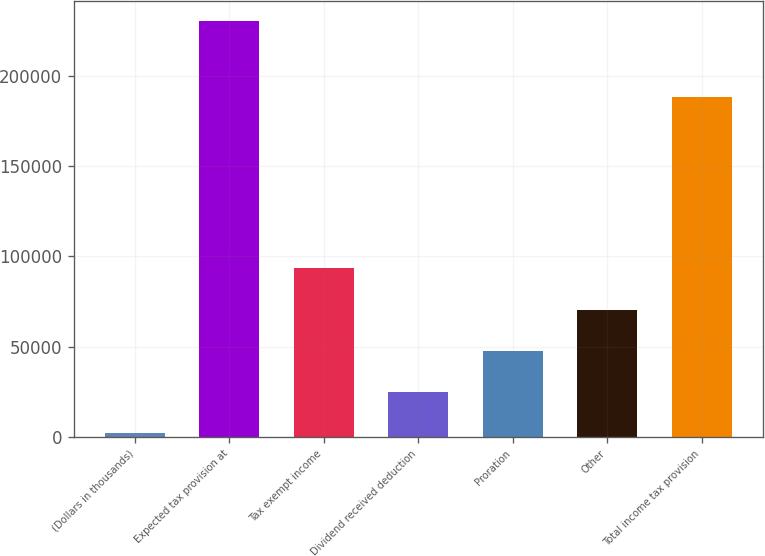<chart> <loc_0><loc_0><loc_500><loc_500><bar_chart><fcel>(Dollars in thousands)<fcel>Expected tax provision at<fcel>Tax exempt income<fcel>Dividend received deduction<fcel>Proration<fcel>Other<fcel>Total income tax provision<nl><fcel>2007<fcel>230288<fcel>93319.4<fcel>24835.1<fcel>47663.2<fcel>70491.3<fcel>188681<nl></chart> 